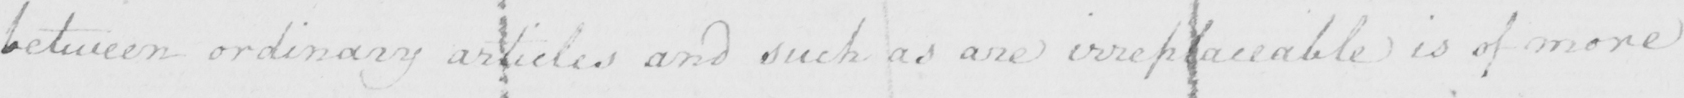Transcribe the text shown in this historical manuscript line. between ordinary articles and such as are irreplaceable is of more 